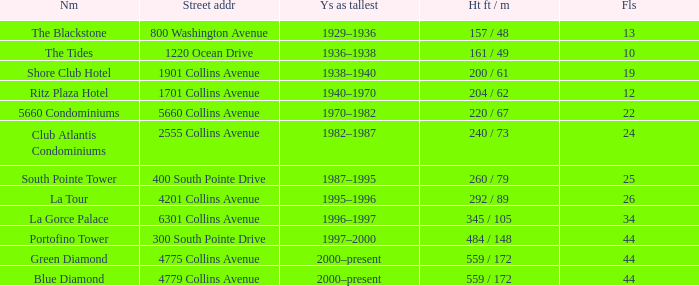What is the height of the Tides with less than 34 floors? 161 / 49. 